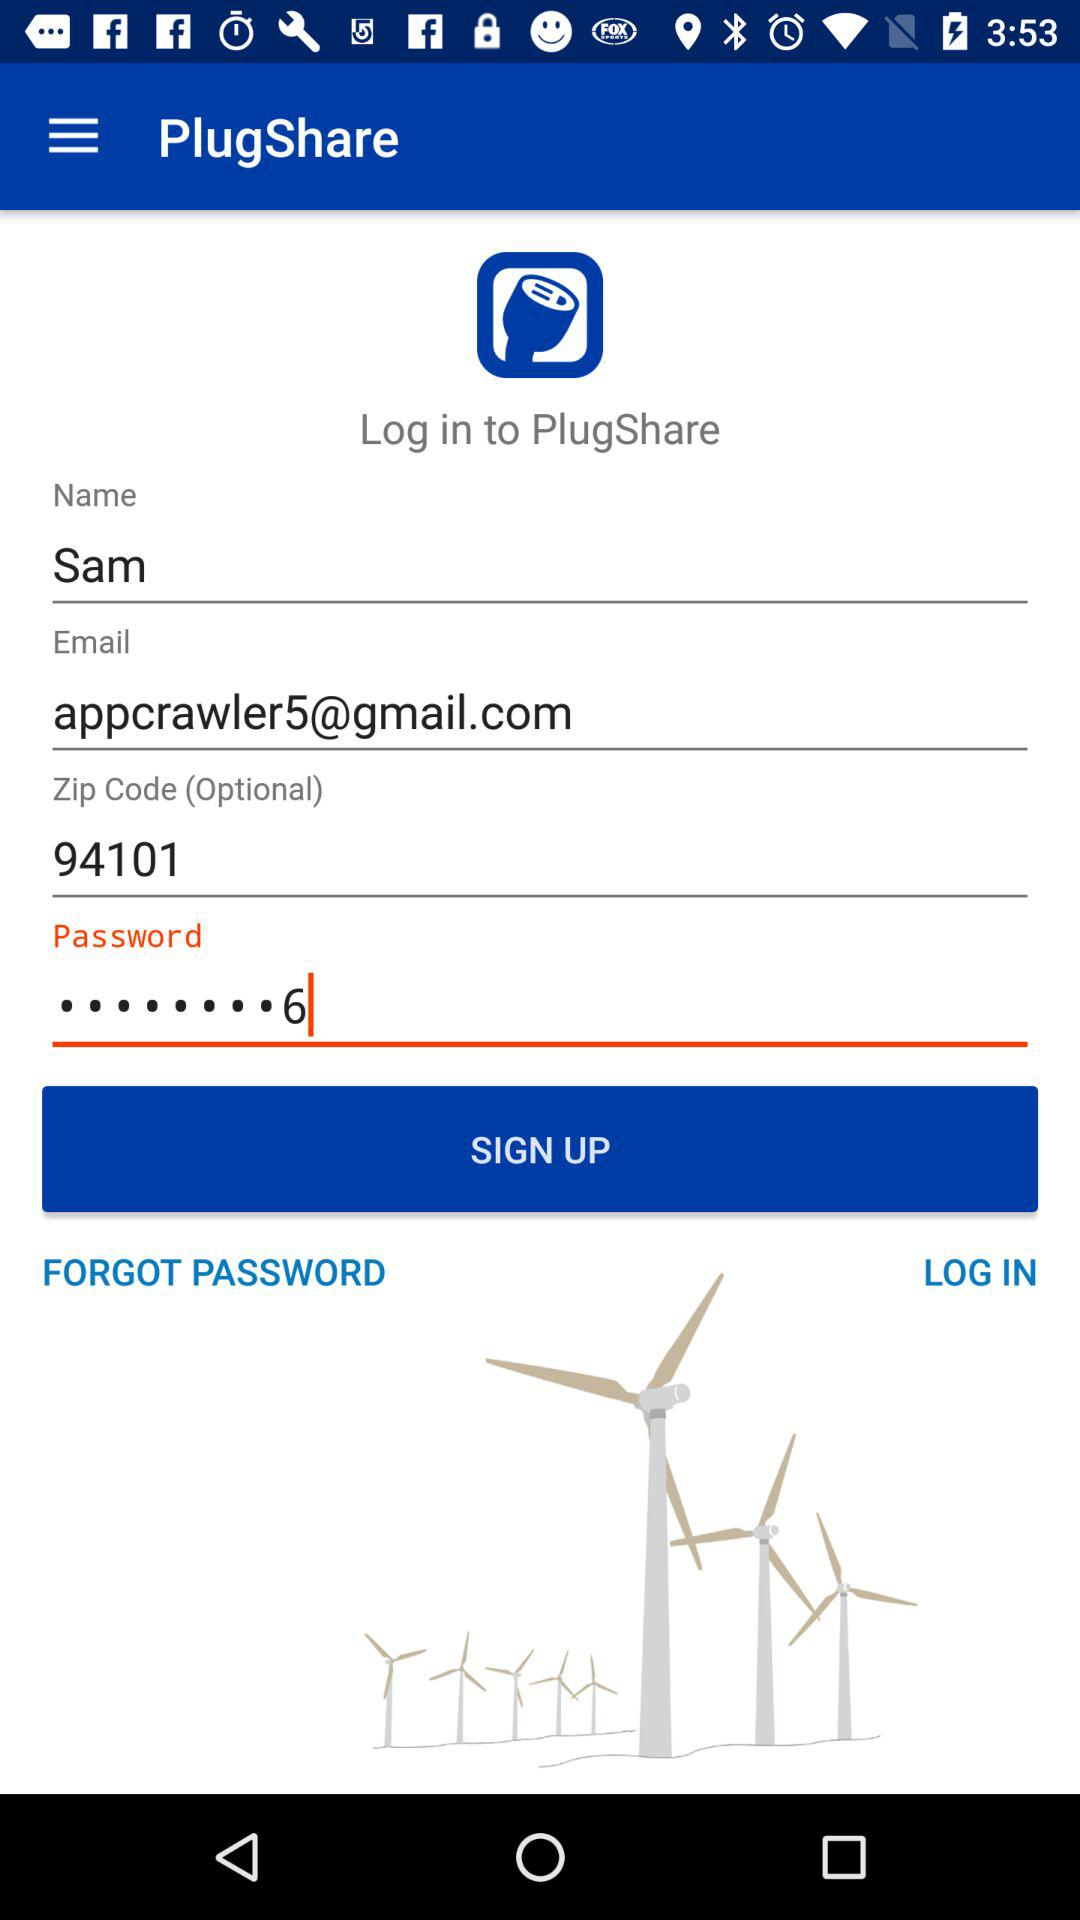Can we reset password?
When the provided information is insufficient, respond with <no answer>. <no answer> 